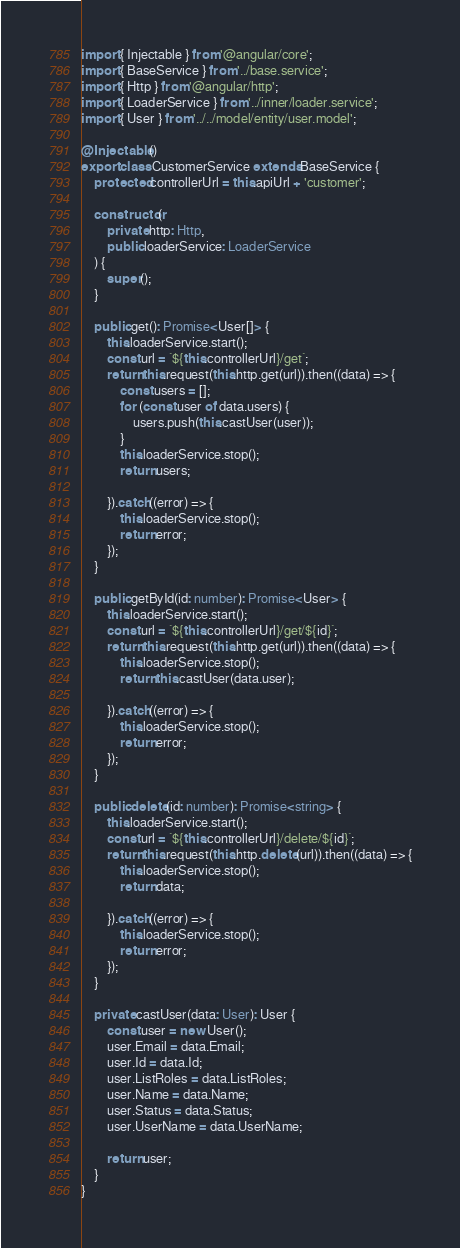<code> <loc_0><loc_0><loc_500><loc_500><_TypeScript_>import { Injectable } from '@angular/core';
import { BaseService } from '../base.service';
import { Http } from '@angular/http';
import { LoaderService } from '../inner/loader.service';
import { User } from '../../model/entity/user.model';

@Injectable()
export class CustomerService extends BaseService {
    protected controllerUrl = this.apiUrl + 'customer';

    constructor(
        private http: Http,
        public loaderService: LoaderService
    ) {
        super();
    }

    public get(): Promise<User[]> {
        this.loaderService.start();
        const url = `${this.controllerUrl}/get`;
        return this.request(this.http.get(url)).then((data) => {
            const users = [];
            for (const user of data.users) {
                users.push(this.castUser(user));
            }
            this.loaderService.stop();
            return users;

        }).catch((error) => {
            this.loaderService.stop();
            return error;
        });
    }

    public getById(id: number): Promise<User> {
        this.loaderService.start();
        const url = `${this.controllerUrl}/get/${id}`;
        return this.request(this.http.get(url)).then((data) => {
            this.loaderService.stop();
            return this.castUser(data.user);

        }).catch((error) => {
            this.loaderService.stop();
            return error;
        });
    }

    public delete(id: number): Promise<string> {
        this.loaderService.start();
        const url = `${this.controllerUrl}/delete/${id}`;
        return this.request(this.http.delete(url)).then((data) => {
            this.loaderService.stop();
            return data;

        }).catch((error) => {
            this.loaderService.stop();
            return error;
        });
    }

    private castUser(data: User): User {
        const user = new User();
        user.Email = data.Email;
        user.Id = data.Id;
        user.ListRoles = data.ListRoles;
        user.Name = data.Name;
        user.Status = data.Status;
        user.UserName = data.UserName;
         
        return user;
    }
}
</code> 